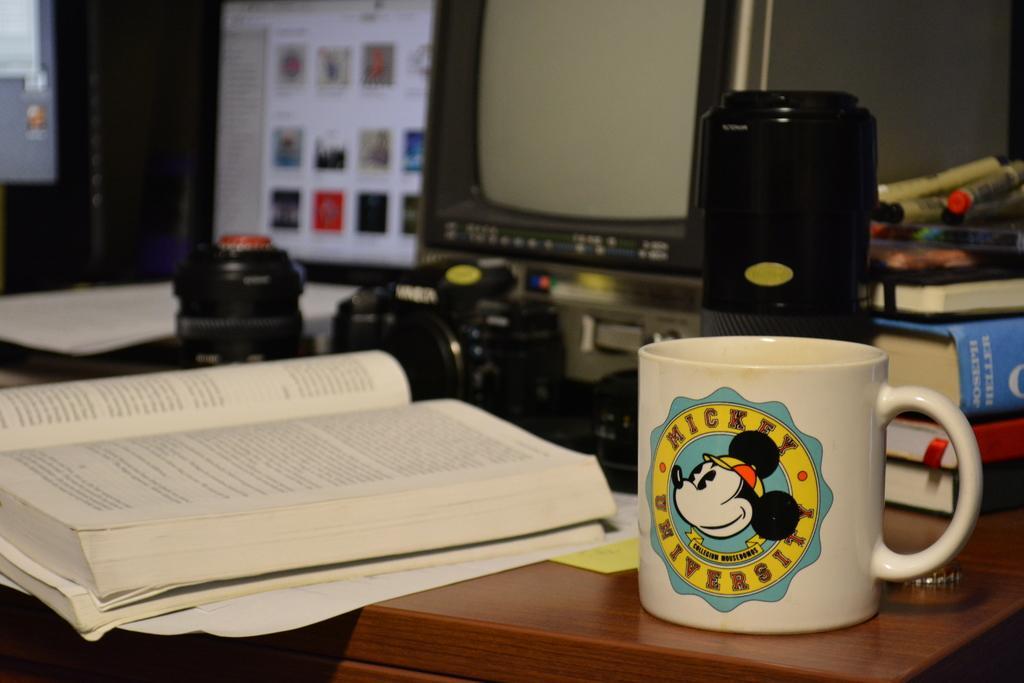Could you give a brief overview of what you see in this image? This image is clicked in a room. In the front, there is a table on which Cup and bottle along with books. In the left, there is a book. In the background there is a monitor and TV along with a camera. 